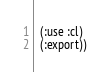Convert code to text. <code><loc_0><loc_0><loc_500><loc_500><_Lisp_>  (:use :cl)
  (:export))
</code> 